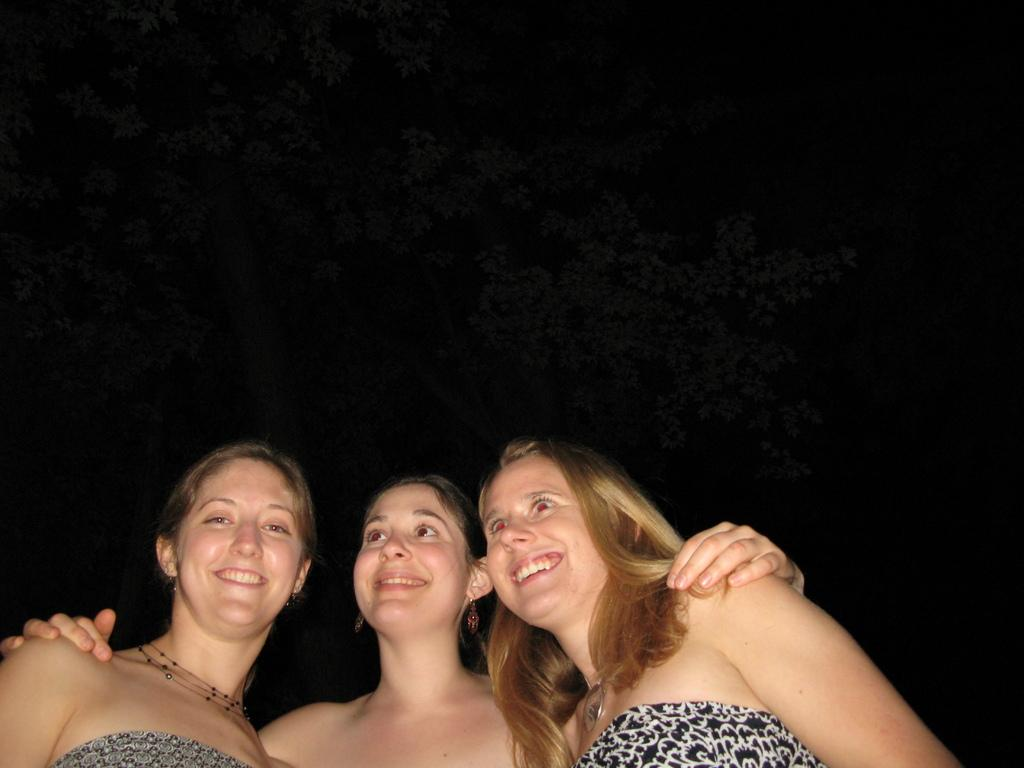How many people are in the image? There are three women in the image. What is the facial expression of the women? The women are smiling in the image. Can you describe the background of the image? The background of the image is dark. What type of jelly can be seen in the image? There is no jelly present in the image. How many rabbits can be seen in the image? There are no rabbits present in the image. 